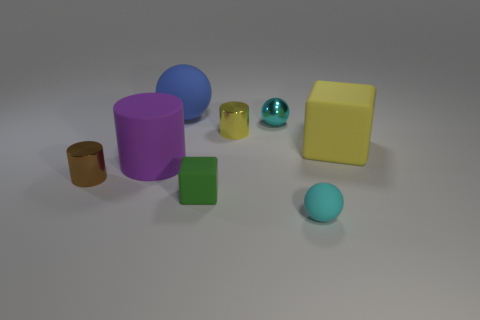There is a cube in front of the cylinder in front of the large purple object; what size is it?
Your answer should be compact. Small. Is there a yellow matte cylinder that has the same size as the brown thing?
Provide a short and direct response. No. The ball that is to the right of the tiny green matte block and behind the brown object is made of what material?
Ensure brevity in your answer.  Metal. How many shiny things are tiny yellow cylinders or big yellow things?
Offer a very short reply. 1. The small cyan object that is the same material as the small block is what shape?
Keep it short and to the point. Sphere. How many small objects are on the right side of the small green rubber block and in front of the yellow shiny cylinder?
Offer a terse response. 1. How big is the shiny cylinder that is left of the blue object?
Make the answer very short. Small. What number of other things are the same color as the matte cylinder?
Provide a succinct answer. 0. What material is the block left of the cylinder that is right of the large purple rubber cylinder?
Provide a short and direct response. Rubber. There is a tiny sphere that is in front of the small green block; is it the same color as the large rubber cylinder?
Offer a terse response. No. 